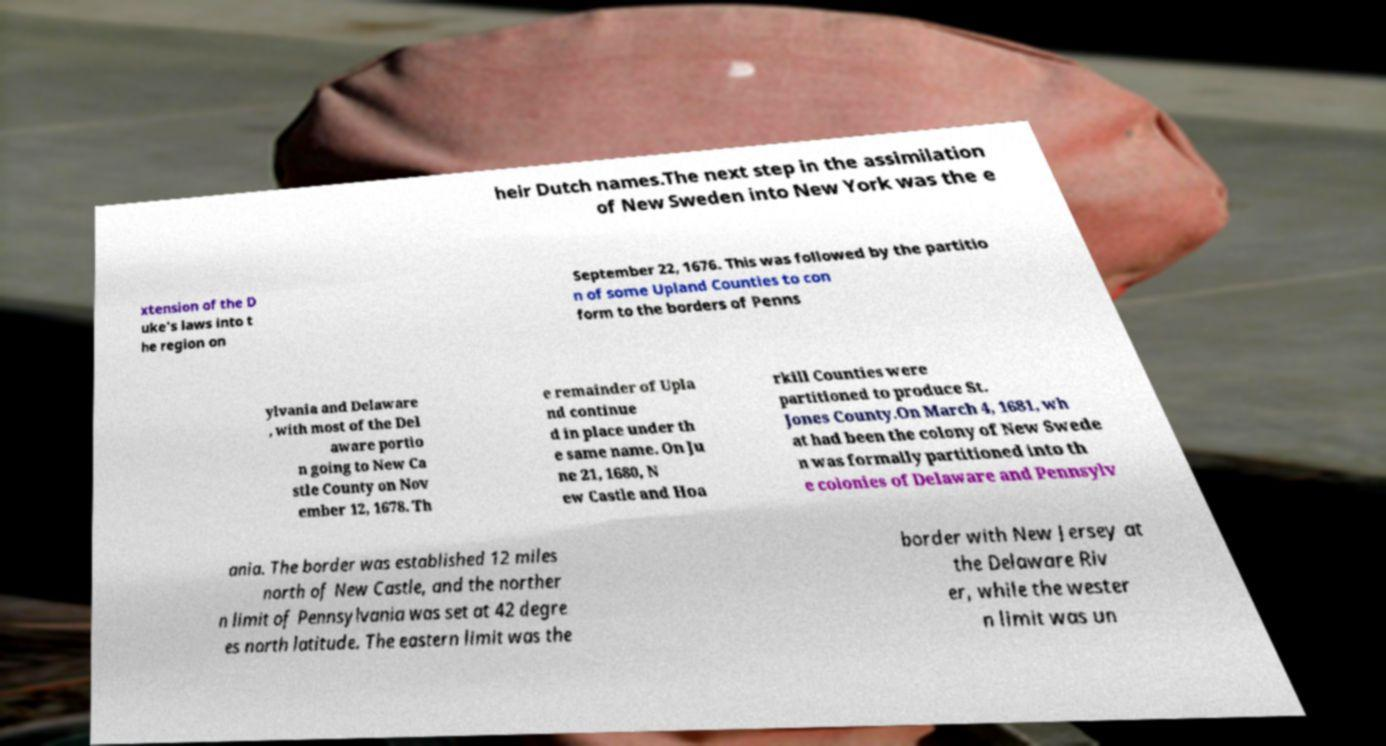Can you accurately transcribe the text from the provided image for me? heir Dutch names.The next step in the assimilation of New Sweden into New York was the e xtension of the D uke's laws into t he region on September 22, 1676. This was followed by the partitio n of some Upland Counties to con form to the borders of Penns ylvania and Delaware , with most of the Del aware portio n going to New Ca stle County on Nov ember 12, 1678. Th e remainder of Upla nd continue d in place under th e same name. On Ju ne 21, 1680, N ew Castle and Hoa rkill Counties were partitioned to produce St. Jones County.On March 4, 1681, wh at had been the colony of New Swede n was formally partitioned into th e colonies of Delaware and Pennsylv ania. The border was established 12 miles north of New Castle, and the norther n limit of Pennsylvania was set at 42 degre es north latitude. The eastern limit was the border with New Jersey at the Delaware Riv er, while the wester n limit was un 